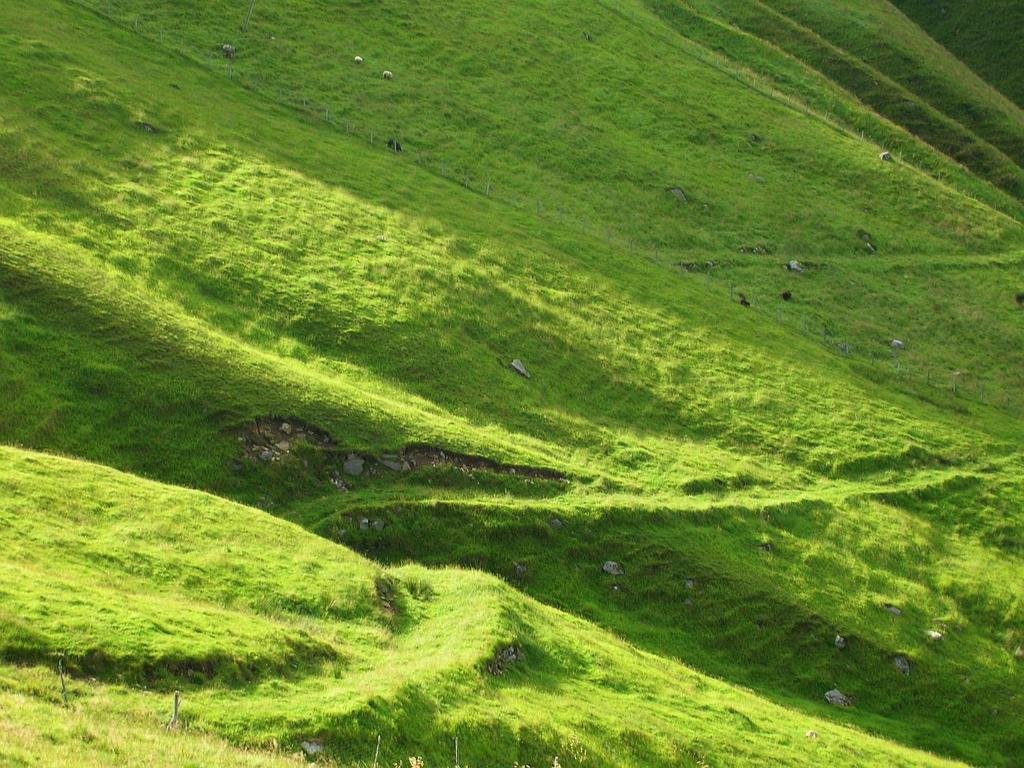What type of natural formation is visible in the picture? There is a mountain in the picture. What type of terrain can be seen at the base of the mountain? There are stones and grass in the picture. What type of fang can be seen in the picture? There is no fang present in the picture; it features a mountain, stones, and grass. What arithmetic problem is being solved on the mountain in the picture? There is no arithmetic problem present in the picture; it features a mountain, stones, and grass. 